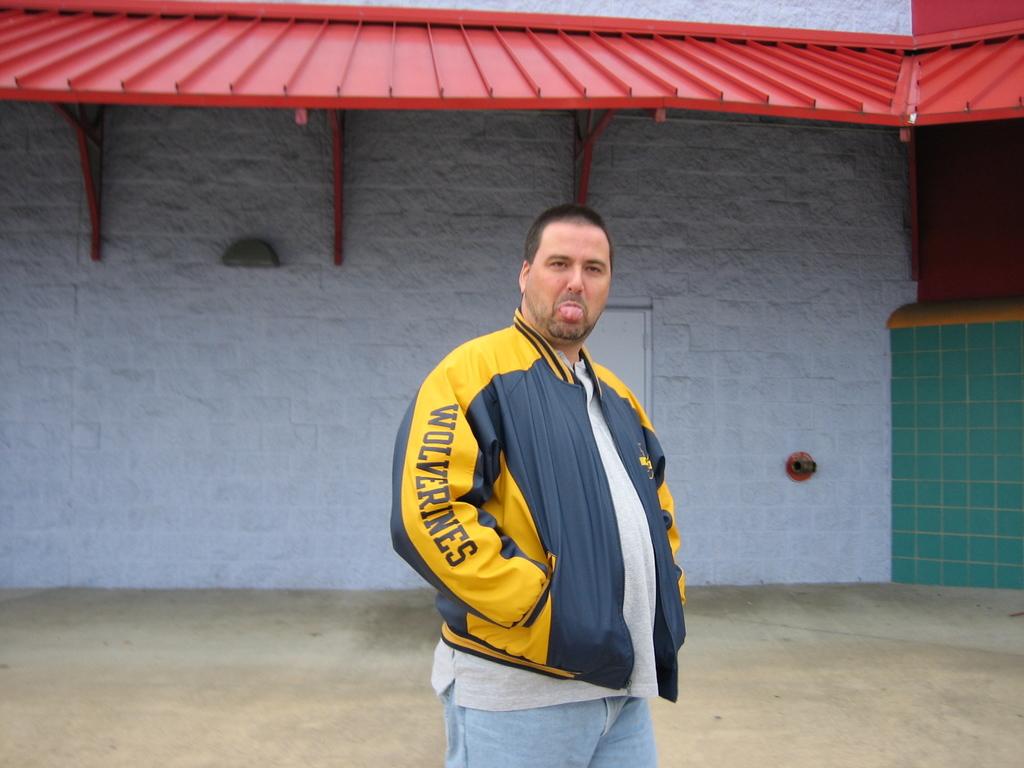What is the name of the team on the jacket?
Your response must be concise. Wolverines. 